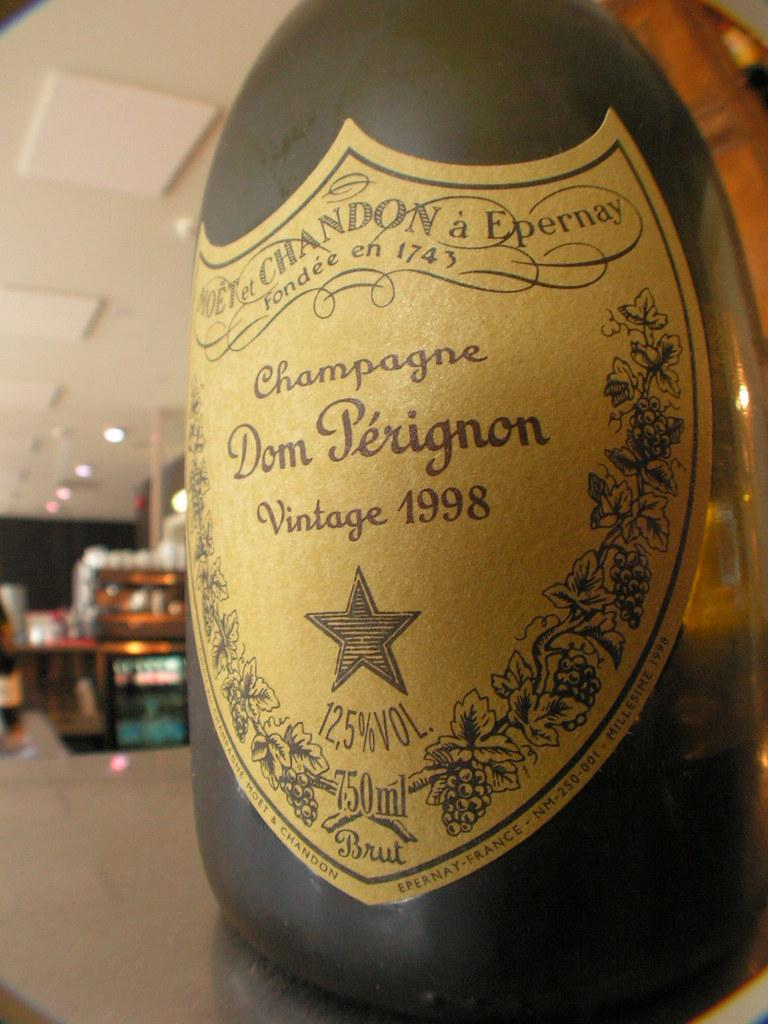<image>
Describe the image concisely. A bottle of Dom Perignon champagne is from 1998. 